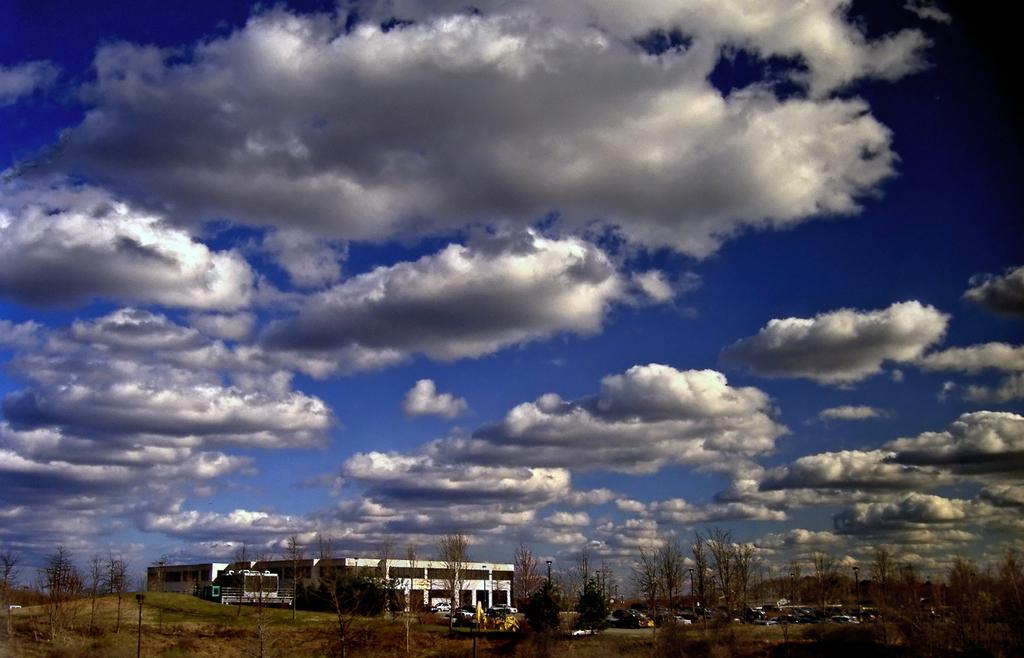Please provide a concise description of this image. At the bottom of the image we can see building, trees, vehicles and grass. In the background we can see sky and clouds. 